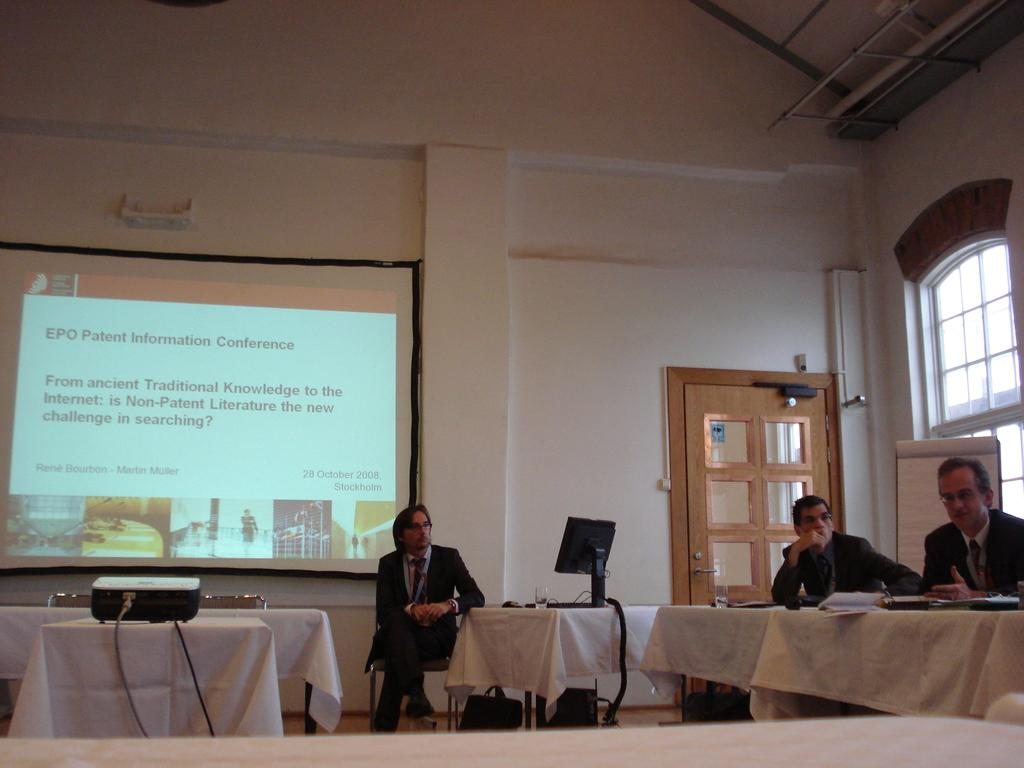What are the people in the image doing? The people in the image are seated on chairs. What is on the table in the image? There are papers on the table. What electronic devices are present in the image? There is a monitor, a projector screen, and a projector in the image. What type of yoke is being used to control the projector in the image? There is no yoke present in the image, and the projector is not being controlled by any yoke. 